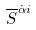Convert formula to latex. <formula><loc_0><loc_0><loc_500><loc_500>\overline { S } ^ { \dot { \alpha } i }</formula> 